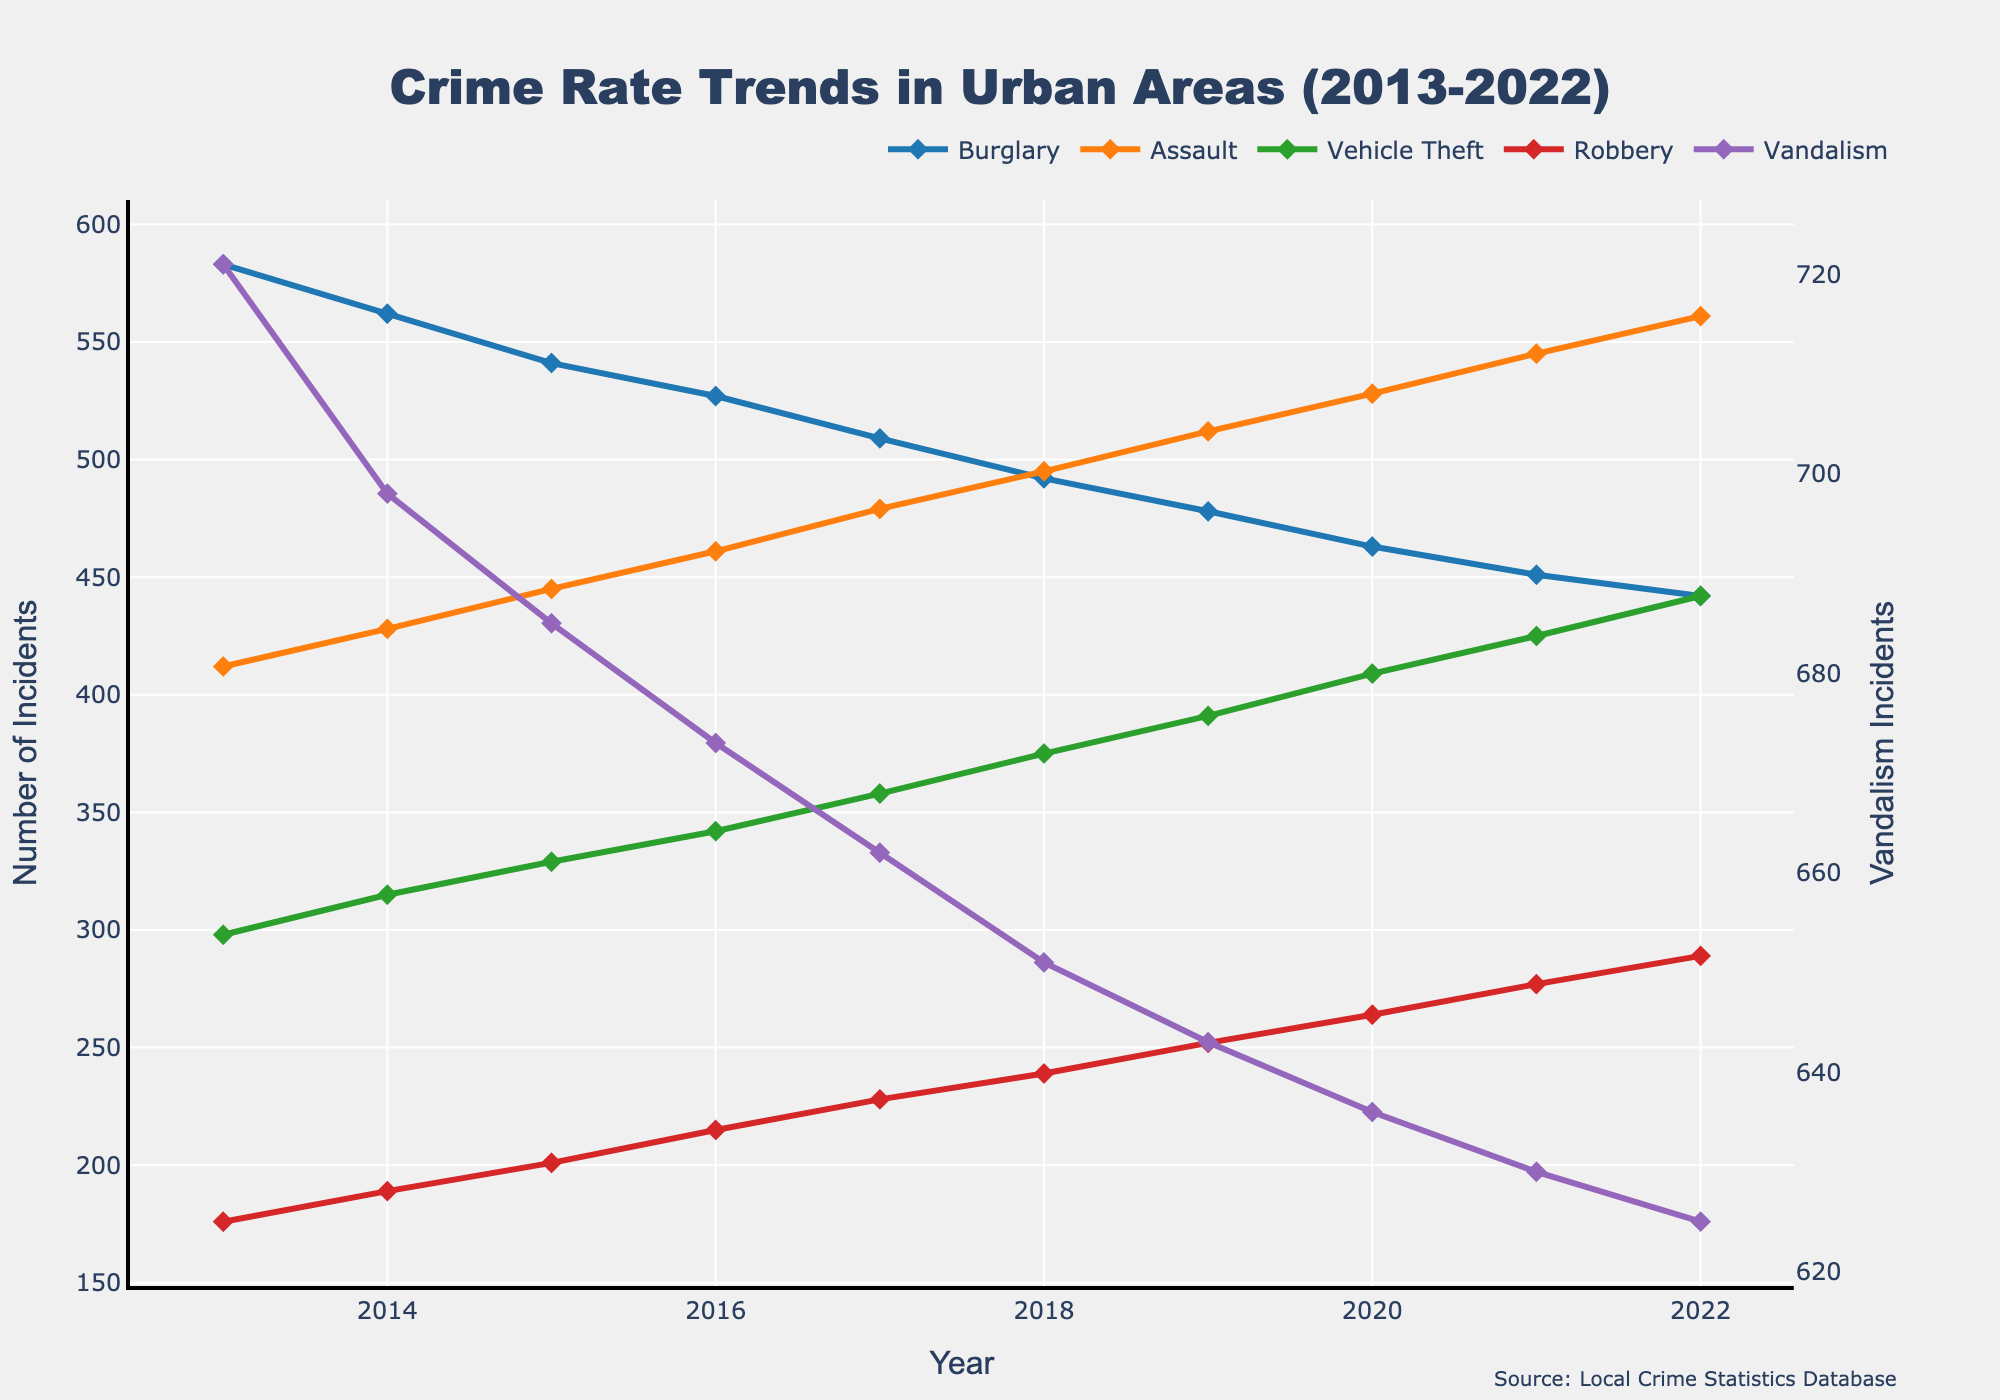What's the overall trend for burglary incidents over the past decade? By visually examining the line representing burglary incidents from 2013 to 2022, we notice a downward slope. This indicates a steady decline in burglary incidents each year.
Answer: Decline Which year had the highest number of assaults? By identifying the peak of the assault line, we can see that the highest point occurs in 2022, indicating the most assaults in that year.
Answer: 2022 In which year was the gap between vehicle theft and robbery incidents the largest? To determine this, compare the difference between the vehicle theft and robbery lines for each year. The largest gap appears in 2013 where vehicle theft is 298, and robbery is 176, making the gap 122.
Answer: 2013 Which offense type showed the most consistent increase over the decade? By examining the slope of each line, it's clear that the assault line rises consistently year-over-year, indicating the most consistent increase.
Answer: Assault How does the number of vandalism incidents in 2022 compare to burglary incidents in the same year? By comparing the values for vandalism and burglary in 2022, we see that vandalism incidents are 625 while burglary incidents are 442. Thus, vandalism incidents are higher.
Answer: Vandalism incidents are higher What is the average number of vehicle theft incidents per year over the past decade? Sum the number of vehicle theft incidents for each year (298 + 315 + 329 + 342 + 358 + 375 + 391 + 409 + 425 + 442) and then divide by 10 to find the average. The total is 3784, so the average is 378.4.
Answer: 378.4 Between 2015 and 2019, which type of crime shows the greatest numerical increase? Calculate the difference for each type of crime between 2015 and 2019. Burglary (541-478=63), Assault (445-512=-67), Vehicle Theft (329-391=62), Robbery (201-252=51), Vandalism (685-643=42). The largest increase is for Vehicle Theft at 62.
Answer: Vehicle Theft By how much did robbery incidents increase from 2013 to 2022? Subtract the number of robbery incidents in 2013 from the number in 2022. Specifically, 289 (2022) - 176 (2013) equals 113.
Answer: 113 Which crime shows a decreasing trend over the entire decade? Observing the slope, burglary shows a constant decline from 2013 to 2022, indicating a decreasing trend.
Answer: Burglary What year had an equal number of vehicle theft and vandalism incidents? Looking across each year, only in 2019 do the lines for vehicle theft (391) and vandalism (643) not match, so no year has an equal count for both. However, no year shows equal counts; the minimum gap is in 2020 but not equal either.
Answer: No year had an equal count 